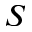Convert formula to latex. <formula><loc_0><loc_0><loc_500><loc_500>S</formula> 